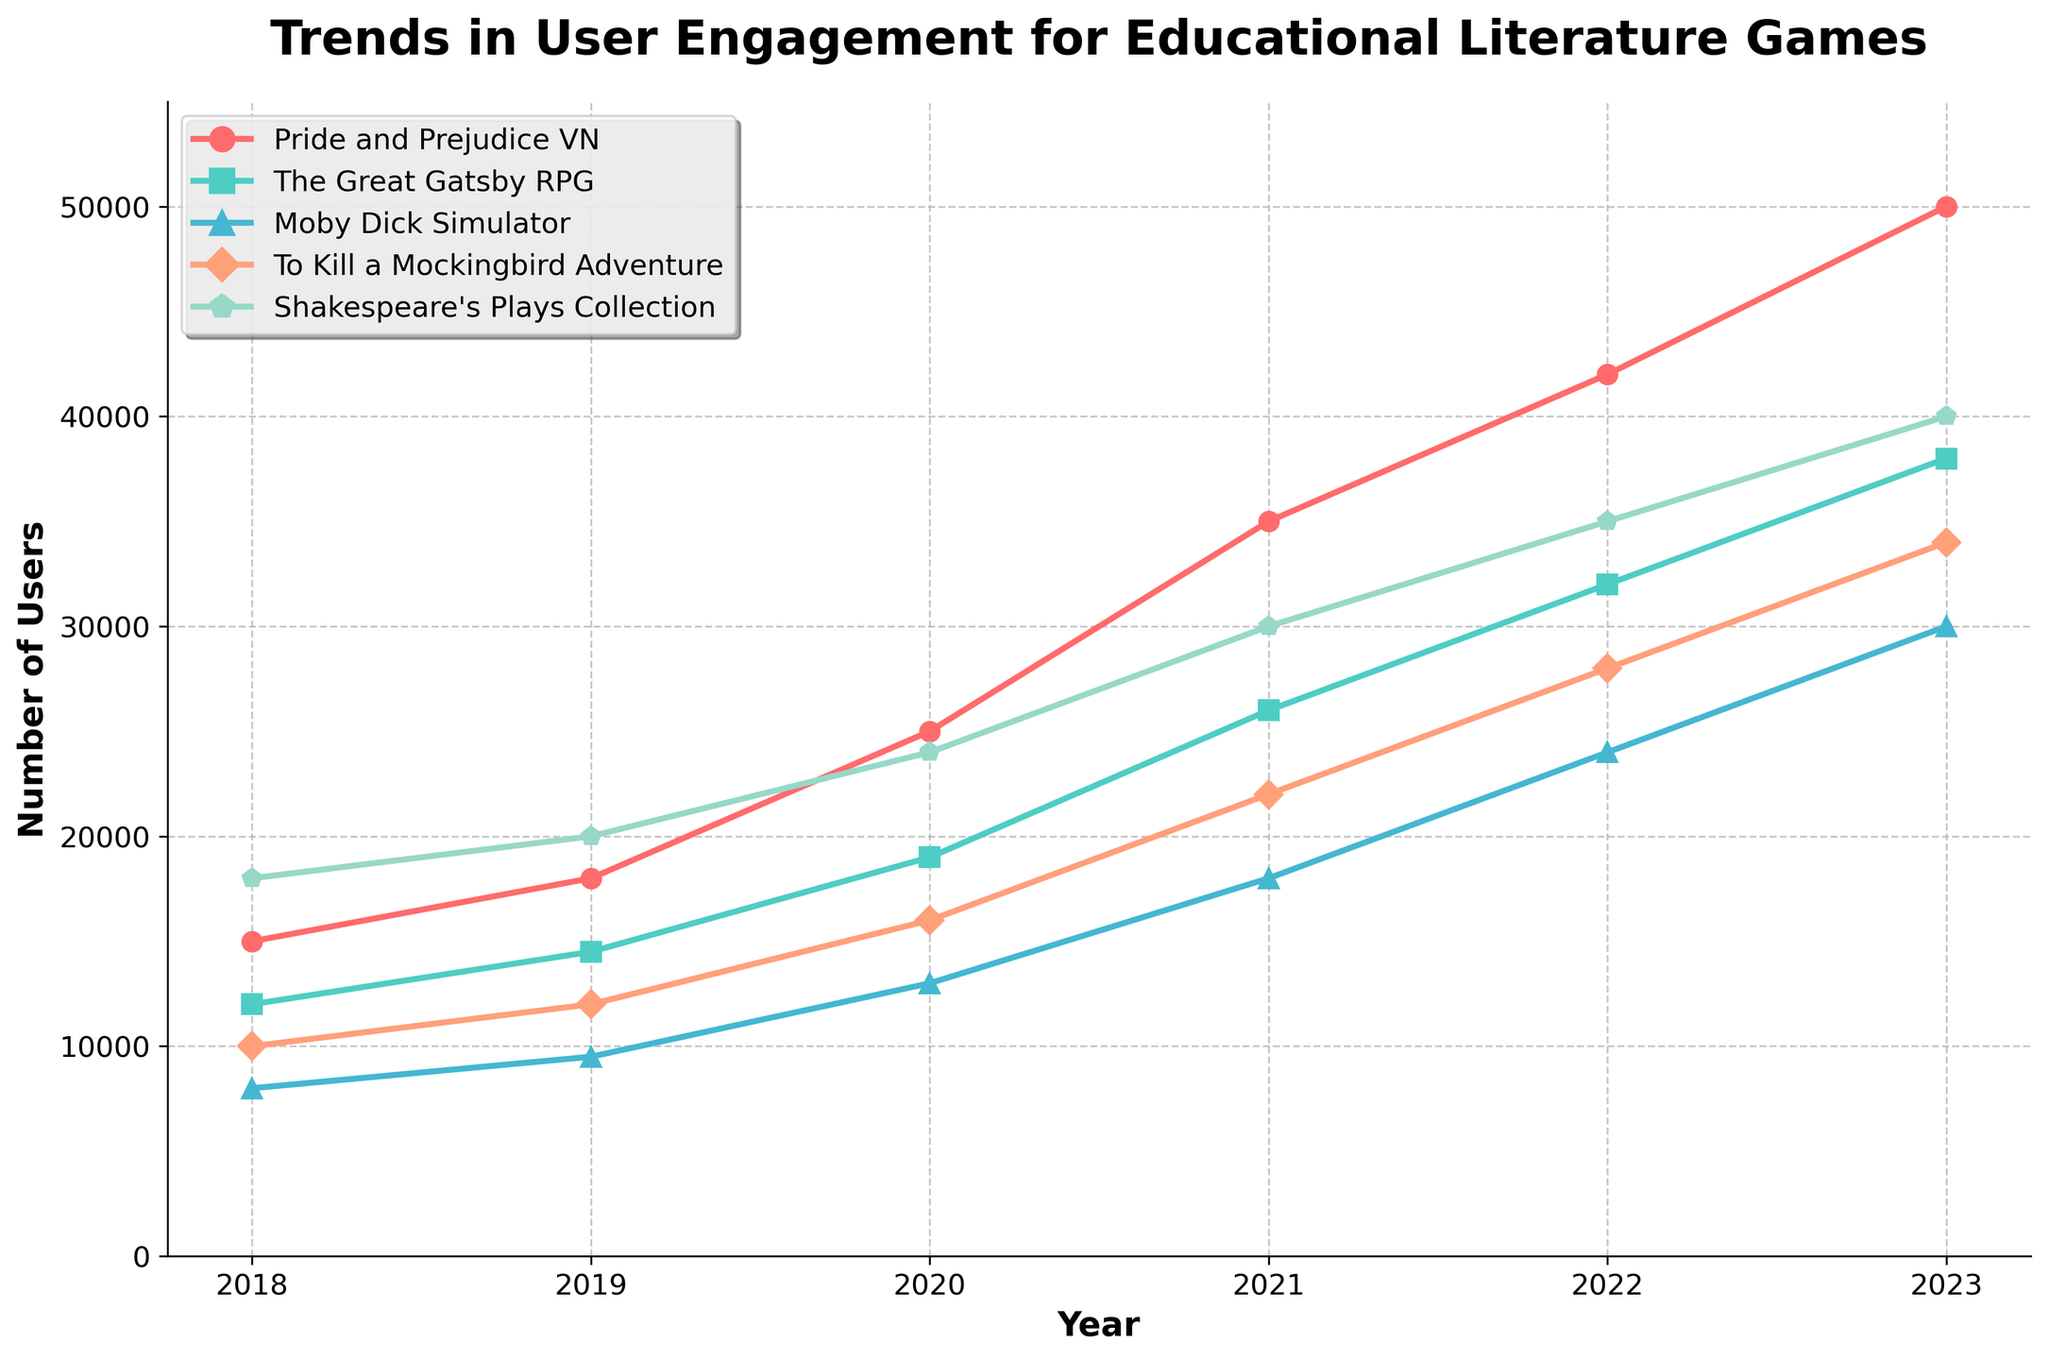Which educational game had the highest user engagement in 2023? By observing the line chart, we can see the end point of each line representing data for 2023. The highest point among all lines corresponds to Shakespeare's Plays Collection.
Answer: Shakespeare's Plays Collection How many users engaged with The Great Gatsby RPG in 2021? Look at the height of the line corresponding to The Great Gatsby RPG (color-coded in green) for the year 2021. It intersects at 26,000 users.
Answer: 26,000 Which game saw the largest increase in user engagement from 2018 to 2023? Calculate the difference between the values for 2023 and 2018 for each game. The differences are:
Pride and Prejudice VN: 50,000 - 15,000 = 35,000
The Great Gatsby RPG: 38,000 - 12,000 = 26,000
Moby Dick Simulator: 30,000 - 8,000 = 22,000
To Kill a Mockingbird Adventure: 34,000 - 10,000 = 24,000
Shakespeare's Plays Collection: 40,000 - 18,000 = 22,000
The largest increase is for Pride and Prejudice VN.
Answer: Pride and Prejudice VN Between 2019 and 2020, which game experienced the highest percentage increase in user engagement? Calculate the percentage increase for each game from 2019 to 2020 using the formula: (Value in 2020 - Value in 2019) / Value in 2019 * 100
Pride and Prejudice VN: (25,000 - 18,000) / 18,000 * 100 = 38.89%
The Great Gatsby RPG: (19,000 - 14,500) / 14,500 * 100 = 31.03%
Moby Dick Simulator: (13,000 - 9,500) / 9,500 * 100 = 36.84%
To Kill a Mockingbird Adventure: (16,000 - 12,000) / 12,000 * 100 = 33.33%
Shakespeare's Plays Collection: (24,000 - 20,000) / 20,000 * 100 = 20%
The highest percentage increase is for Pride and Prejudice VN.
Answer: Pride and Prejudice VN What is the total user engagement for all games combined in the year 2022? Add the number of users for each game in 2022:
Pride and Prejudice VN: 42,000
The Great Gatsby RPG: 32,000
Moby Dick Simulator: 24,000
To Kill a Mockingbird Adventure: 28,000
Shakespeare's Plays Collection: 35,000
Total = 42,000 + 32,000 + 24,000 + 28,000 + 35,000 = 161,000
Answer: 161,000 Which game had its lowest user engagement before 2020? By looking at the line chart, we can identify the lowest points before 2020 for each game. The lowest value is for Moby Dick Simulator in 2018 with 8,000 users.
Answer: Moby Dick Simulator 